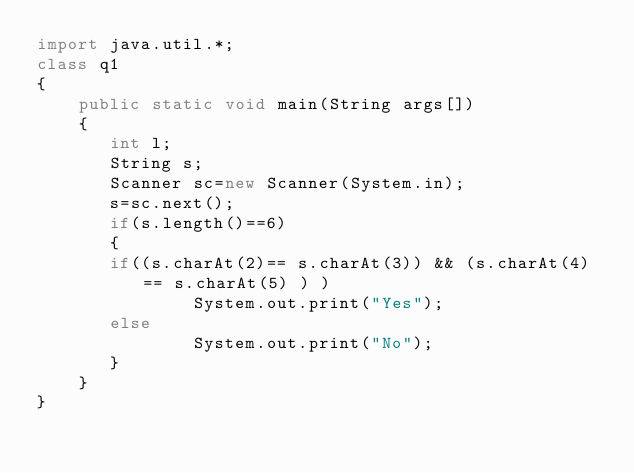Convert code to text. <code><loc_0><loc_0><loc_500><loc_500><_Java_>import java.util.*;
class q1
{
    public static void main(String args[])
    {
       int l;
       String s;
       Scanner sc=new Scanner(System.in);
       s=sc.next();
       if(s.length()==6)
       {
       if((s.charAt(2)== s.charAt(3)) && (s.charAt(4) == s.charAt(5) ) )
               System.out.print("Yes");
       else
               System.out.print("No");
       }
    }
}</code> 